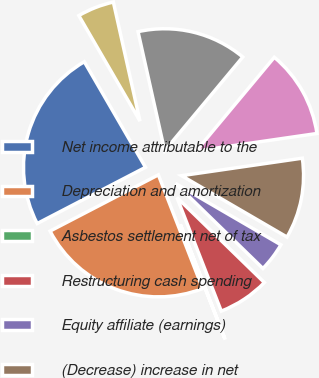Convert chart to OTSL. <chart><loc_0><loc_0><loc_500><loc_500><pie_chart><fcel>Net income attributable to the<fcel>Depreciation and amortization<fcel>Asbestos settlement net of tax<fcel>Restructuring cash spending<fcel>Equity affiliate (earnings)<fcel>(Decrease) increase in net<fcel>(Increase)/decrease in<fcel>Decrease (increase) in other<fcel>Increase/(decrease) in<nl><fcel>24.26%<fcel>23.29%<fcel>0.01%<fcel>6.8%<fcel>3.89%<fcel>10.68%<fcel>11.65%<fcel>14.56%<fcel>4.86%<nl></chart> 